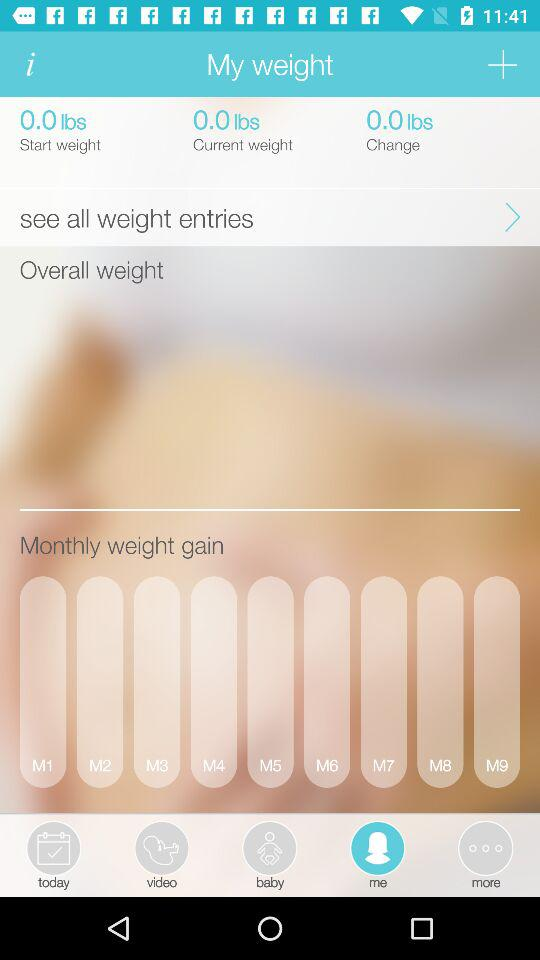What is the start weight? The start weight is 0.0 lbs. 